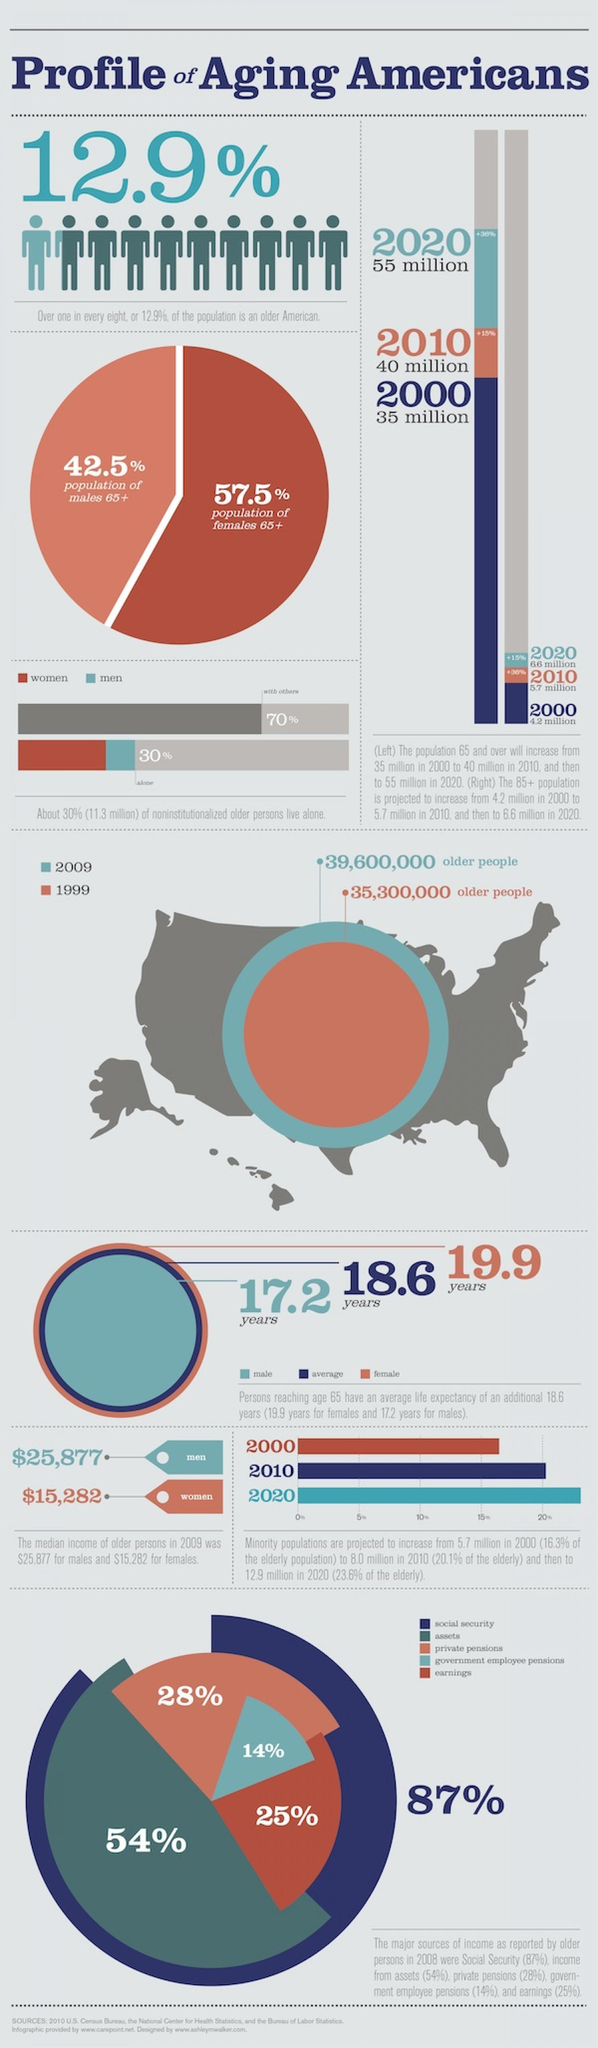Draw attention to some important aspects in this diagram. According to the information provided, the percentage of social security and assets taken together is 141%. The earnings and assets taken together are equivalent to 79% of the total. 